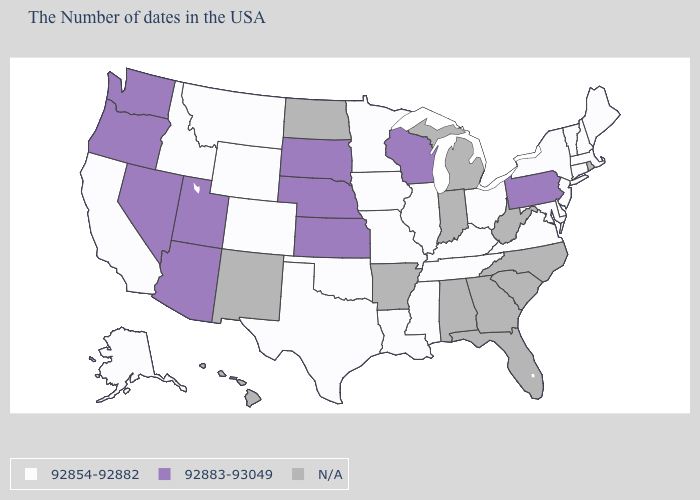What is the value of Mississippi?
Answer briefly. 92854-92882. What is the value of Massachusetts?
Short answer required. 92854-92882. What is the value of Maryland?
Answer briefly. 92854-92882. How many symbols are there in the legend?
Quick response, please. 3. Among the states that border Colorado , does Oklahoma have the lowest value?
Give a very brief answer. Yes. Name the states that have a value in the range 92883-93049?
Keep it brief. Pennsylvania, Wisconsin, Kansas, Nebraska, South Dakota, Utah, Arizona, Nevada, Washington, Oregon. Among the states that border North Carolina , which have the highest value?
Quick response, please. Virginia, Tennessee. Which states hav the highest value in the MidWest?
Be succinct. Wisconsin, Kansas, Nebraska, South Dakota. Name the states that have a value in the range 92883-93049?
Quick response, please. Pennsylvania, Wisconsin, Kansas, Nebraska, South Dakota, Utah, Arizona, Nevada, Washington, Oregon. Is the legend a continuous bar?
Give a very brief answer. No. Which states have the lowest value in the USA?
Write a very short answer. Maine, Massachusetts, New Hampshire, Vermont, Connecticut, New York, New Jersey, Delaware, Maryland, Virginia, Ohio, Kentucky, Tennessee, Illinois, Mississippi, Louisiana, Missouri, Minnesota, Iowa, Oklahoma, Texas, Wyoming, Colorado, Montana, Idaho, California, Alaska. Which states have the lowest value in the USA?
Answer briefly. Maine, Massachusetts, New Hampshire, Vermont, Connecticut, New York, New Jersey, Delaware, Maryland, Virginia, Ohio, Kentucky, Tennessee, Illinois, Mississippi, Louisiana, Missouri, Minnesota, Iowa, Oklahoma, Texas, Wyoming, Colorado, Montana, Idaho, California, Alaska. What is the value of Maine?
Quick response, please. 92854-92882. 